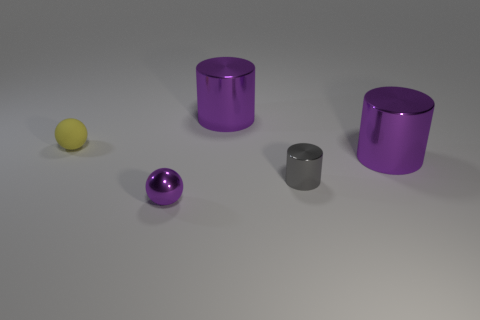Add 3 tiny gray shiny cubes. How many objects exist? 8 Subtract all spheres. How many objects are left? 3 Subtract 0 gray cubes. How many objects are left? 5 Subtract all tiny cyan blocks. Subtract all purple cylinders. How many objects are left? 3 Add 2 big purple objects. How many big purple objects are left? 4 Add 5 purple shiny objects. How many purple shiny objects exist? 8 